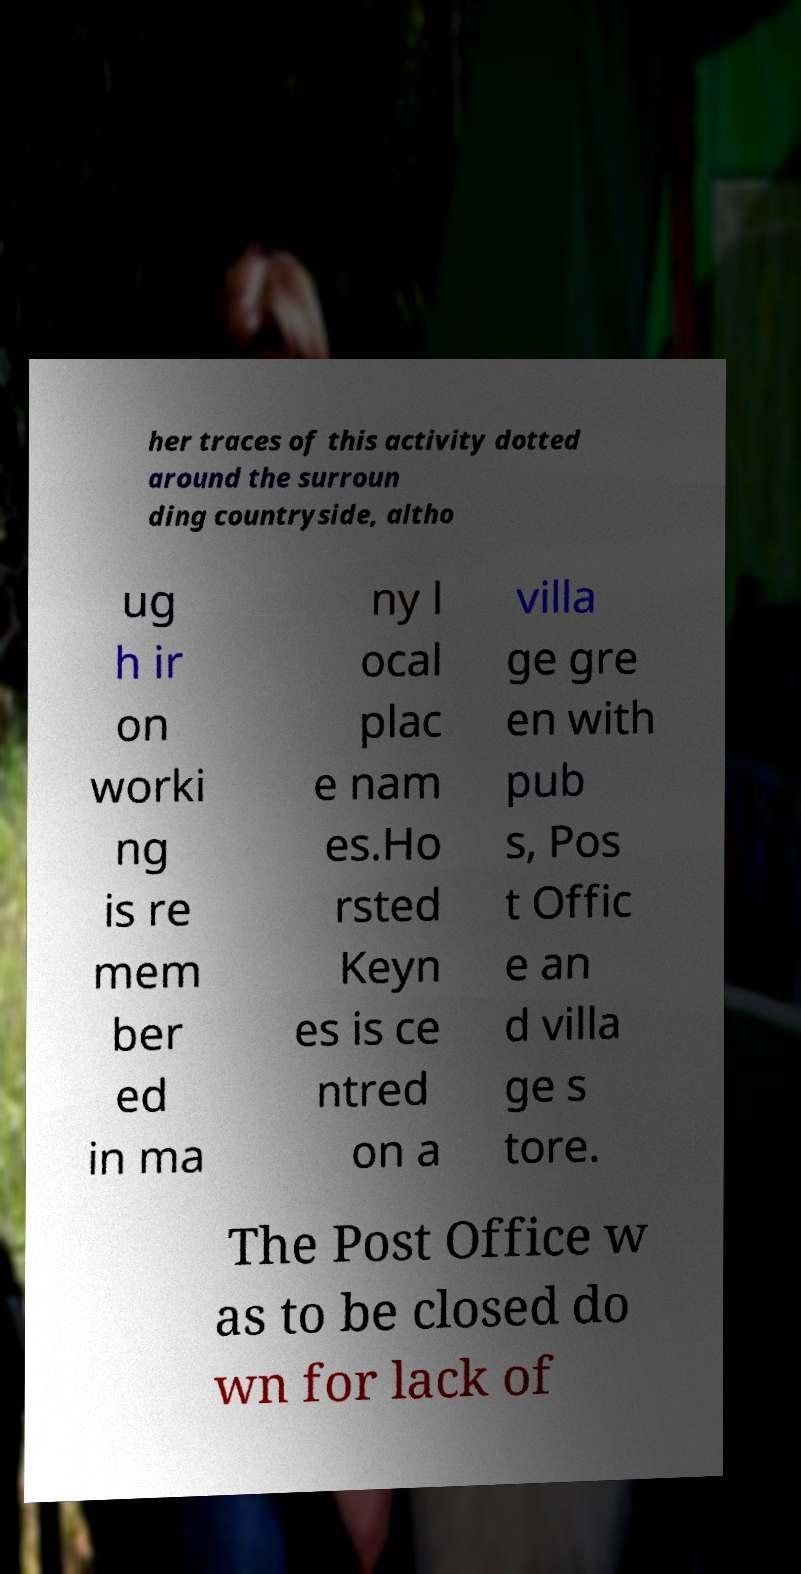Can you accurately transcribe the text from the provided image for me? her traces of this activity dotted around the surroun ding countryside, altho ug h ir on worki ng is re mem ber ed in ma ny l ocal plac e nam es.Ho rsted Keyn es is ce ntred on a villa ge gre en with pub s, Pos t Offic e an d villa ge s tore. The Post Office w as to be closed do wn for lack of 